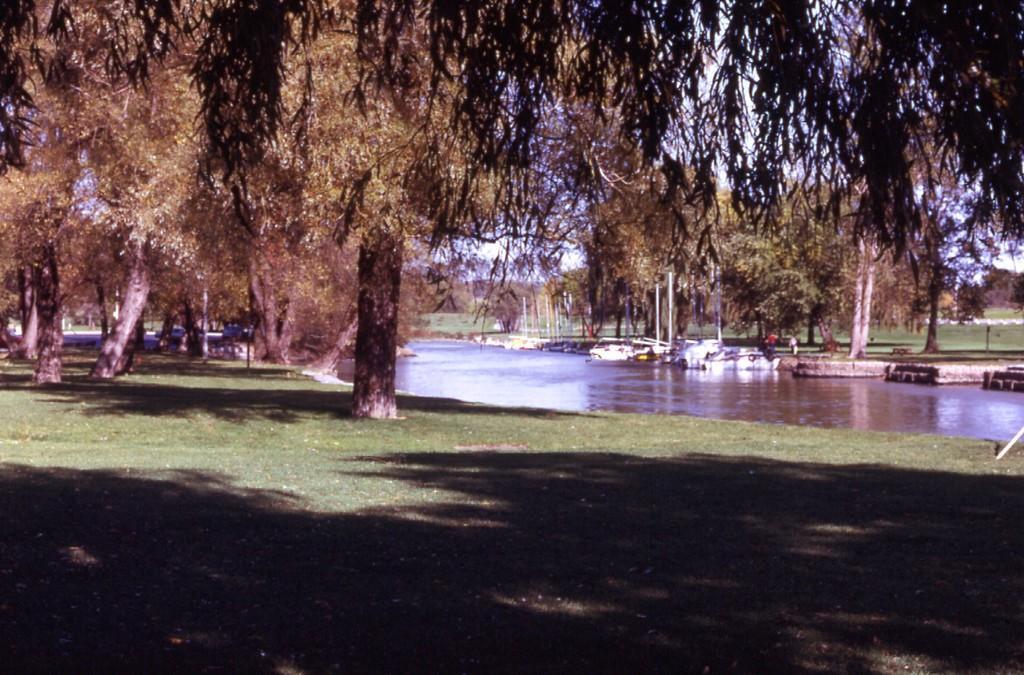Describe this image in one or two sentences. In this image there is a green grass at the bottom. There are trees, ships, water and people in the foreground. There are trees and green grass in the background. And there is a sky at the top. 